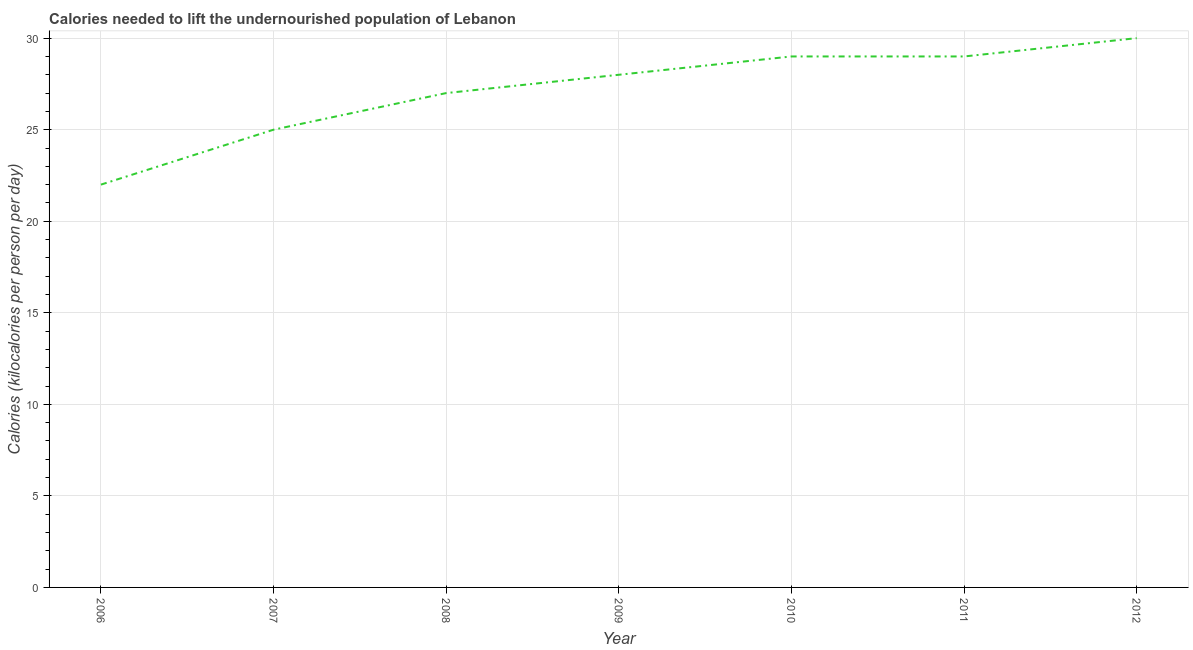What is the depth of food deficit in 2008?
Offer a very short reply. 27. Across all years, what is the maximum depth of food deficit?
Provide a short and direct response. 30. Across all years, what is the minimum depth of food deficit?
Keep it short and to the point. 22. In which year was the depth of food deficit maximum?
Ensure brevity in your answer.  2012. What is the sum of the depth of food deficit?
Offer a very short reply. 190. What is the difference between the depth of food deficit in 2006 and 2009?
Make the answer very short. -6. What is the average depth of food deficit per year?
Your answer should be very brief. 27.14. What is the ratio of the depth of food deficit in 2006 to that in 2009?
Your response must be concise. 0.79. Is the difference between the depth of food deficit in 2009 and 2012 greater than the difference between any two years?
Make the answer very short. No. Is the sum of the depth of food deficit in 2008 and 2009 greater than the maximum depth of food deficit across all years?
Offer a very short reply. Yes. What is the difference between the highest and the lowest depth of food deficit?
Provide a short and direct response. 8. In how many years, is the depth of food deficit greater than the average depth of food deficit taken over all years?
Keep it short and to the point. 4. How many lines are there?
Your response must be concise. 1. How many years are there in the graph?
Provide a succinct answer. 7. What is the difference between two consecutive major ticks on the Y-axis?
Provide a short and direct response. 5. Does the graph contain grids?
Make the answer very short. Yes. What is the title of the graph?
Ensure brevity in your answer.  Calories needed to lift the undernourished population of Lebanon. What is the label or title of the Y-axis?
Offer a terse response. Calories (kilocalories per person per day). What is the Calories (kilocalories per person per day) in 2008?
Offer a very short reply. 27. What is the Calories (kilocalories per person per day) of 2009?
Offer a terse response. 28. What is the Calories (kilocalories per person per day) in 2011?
Your answer should be compact. 29. What is the Calories (kilocalories per person per day) of 2012?
Keep it short and to the point. 30. What is the difference between the Calories (kilocalories per person per day) in 2006 and 2007?
Offer a terse response. -3. What is the difference between the Calories (kilocalories per person per day) in 2006 and 2010?
Your response must be concise. -7. What is the difference between the Calories (kilocalories per person per day) in 2007 and 2008?
Keep it short and to the point. -2. What is the difference between the Calories (kilocalories per person per day) in 2007 and 2011?
Provide a succinct answer. -4. What is the difference between the Calories (kilocalories per person per day) in 2008 and 2009?
Offer a very short reply. -1. What is the difference between the Calories (kilocalories per person per day) in 2008 and 2010?
Give a very brief answer. -2. What is the difference between the Calories (kilocalories per person per day) in 2008 and 2011?
Your answer should be compact. -2. What is the difference between the Calories (kilocalories per person per day) in 2008 and 2012?
Ensure brevity in your answer.  -3. What is the difference between the Calories (kilocalories per person per day) in 2010 and 2012?
Your answer should be compact. -1. What is the ratio of the Calories (kilocalories per person per day) in 2006 to that in 2007?
Provide a succinct answer. 0.88. What is the ratio of the Calories (kilocalories per person per day) in 2006 to that in 2008?
Your response must be concise. 0.81. What is the ratio of the Calories (kilocalories per person per day) in 2006 to that in 2009?
Keep it short and to the point. 0.79. What is the ratio of the Calories (kilocalories per person per day) in 2006 to that in 2010?
Offer a very short reply. 0.76. What is the ratio of the Calories (kilocalories per person per day) in 2006 to that in 2011?
Provide a short and direct response. 0.76. What is the ratio of the Calories (kilocalories per person per day) in 2006 to that in 2012?
Provide a succinct answer. 0.73. What is the ratio of the Calories (kilocalories per person per day) in 2007 to that in 2008?
Offer a terse response. 0.93. What is the ratio of the Calories (kilocalories per person per day) in 2007 to that in 2009?
Provide a succinct answer. 0.89. What is the ratio of the Calories (kilocalories per person per day) in 2007 to that in 2010?
Provide a short and direct response. 0.86. What is the ratio of the Calories (kilocalories per person per day) in 2007 to that in 2011?
Make the answer very short. 0.86. What is the ratio of the Calories (kilocalories per person per day) in 2007 to that in 2012?
Offer a very short reply. 0.83. What is the ratio of the Calories (kilocalories per person per day) in 2009 to that in 2012?
Keep it short and to the point. 0.93. What is the ratio of the Calories (kilocalories per person per day) in 2010 to that in 2011?
Keep it short and to the point. 1. What is the ratio of the Calories (kilocalories per person per day) in 2010 to that in 2012?
Make the answer very short. 0.97. 